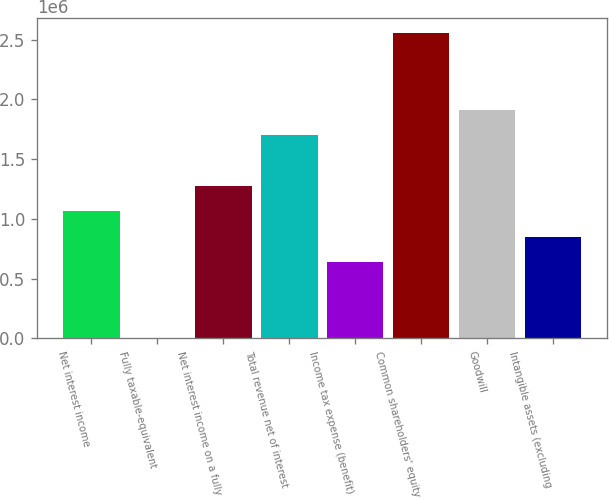Convert chart. <chart><loc_0><loc_0><loc_500><loc_500><bar_chart><fcel>Net interest income<fcel>Fully taxable-equivalent<fcel>Net interest income on a fully<fcel>Total revenue net of interest<fcel>Income tax expense (benefit)<fcel>Common shareholders' equity<fcel>Goodwill<fcel>Intangible assets (excluding<nl><fcel>1.06343e+06<fcel>213<fcel>1.27608e+06<fcel>1.70136e+06<fcel>638145<fcel>2.55194e+06<fcel>1.91401e+06<fcel>850789<nl></chart> 